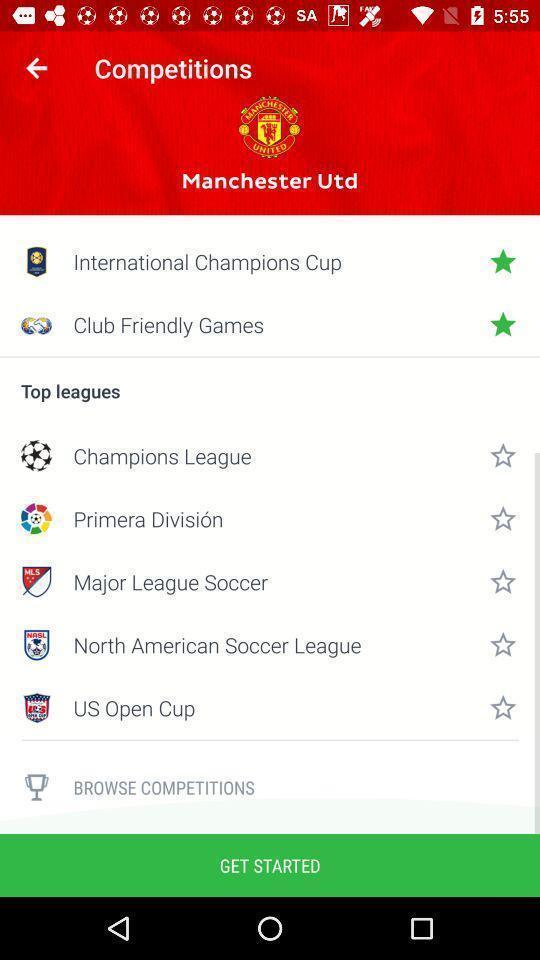Tell me what you see in this picture. Page showing list of top leagues in gaming app. 